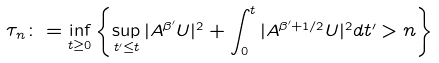<formula> <loc_0><loc_0><loc_500><loc_500>\tau _ { n } \colon = \inf _ { t \geq 0 } \left \{ \sup _ { t ^ { \prime } \leq t } | A ^ { \beta ^ { \prime } } U | ^ { 2 } + \int _ { 0 } ^ { t } | A ^ { \beta ^ { \prime } + 1 / 2 } U | ^ { 2 } d t ^ { \prime } > n \right \}</formula> 